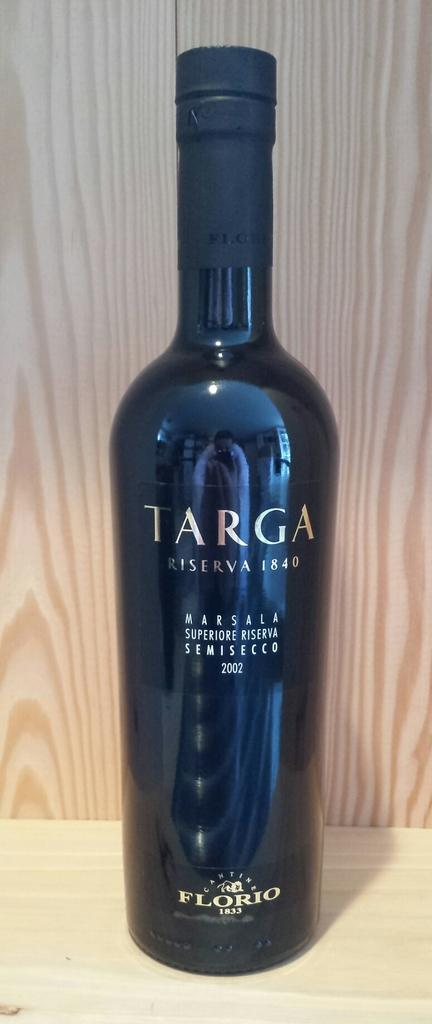<image>
Render a clear and concise summary of the photo. A bottle of Targa wine from 2002 sits on a wood shelf. 